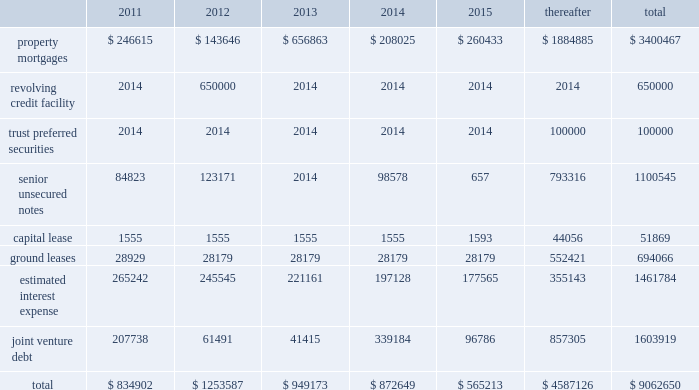Off-balance-sheet arrangements we have a number of off-balance-sheet investments , including joint ven- tures and debt and preferred equity investments .
These investments all have varying ownership structures .
Substantially all of our joint venture arrangements are accounted for under the equity method of accounting as we have the ability to exercise significant influence , but not control over the operating and financial decisions of these joint venture arrange- ments .
Our off-balance-sheet arrangements are discussed in note a0 5 , 201cdebt and preferred equity investments 201d and note a0 6 , 201cinvestments in unconsolidated joint ventures 201d in the accompanying consolidated finan- cial statements .
Additional information about the debt of our unconsoli- dated joint ventures is included in 201ccontractual obligations 201d below .
Capital expenditures we estimate that , for the year ending december a031 , 2011 , we will incur approximately $ 120.5 a0 million of capital expenditures , which are net of loan reserves ( including tenant improvements and leasing commis- sions ) , on existing wholly-owned properties , and that our share of capital expenditures at our joint venture properties , net of loan reserves , will be approximately $ 23.4 a0million .
We expect to fund these capital expen- ditures with operating cash flow , additional property level mortgage financings and cash on hand .
Future property acquisitions may require substantial capital investments for refurbishment and leasing costs .
We expect that these financing requirements will be met in a similar fashion .
We believe that we will have sufficient resources to satisfy our capital needs during the next 12-month period .
Thereafter , we expect our capital needs will be met through a combination of cash on hand , net cash provided by operations , borrowings , potential asset sales or addi- tional equity or debt issuances .
Above provides that , except to enable us to continue to qualify as a reit for federal income tax purposes , we will not during any four consecu- tive fiscal quarters make distributions with respect to common stock or other equity interests in an aggregate amount in excess of 95% ( 95 % ) of funds from operations for such period , subject to certain other adjustments .
As of december a0 31 , 2010 and 2009 , we were in compliance with all such covenants .
Market rate risk we are exposed to changes in interest rates primarily from our floating rate borrowing arrangements .
We use interest rate derivative instruments to manage exposure to interest rate changes .
A hypothetical 100 basis point increase in interest rates along the entire interest rate curve for 2010 and 2009 , would increase our annual interest cost by approximately $ 11.0 a0mil- lion and $ 15.2 a0million and would increase our share of joint venture annual interest cost by approximately $ 6.7 a0million and $ 6.4 a0million , respectively .
We recognize all derivatives on the balance sheet at fair value .
Derivatives that are not hedges must be adjusted to fair value through income .
If a derivative is a hedge , depending on the nature of the hedge , changes in the fair value of the derivative will either be offset against the change in fair value of the hedged asset , liability , or firm commitment through earnings , or recognized in other comprehensive income until the hedged item is recognized in earnings .
The ineffective portion of a deriva- tive 2019s change in fair value is recognized immediately in earnings .
Approximately $ 4.1 a0billion of our long-term debt bore interest at fixed rates , and therefore the fair value of these instruments is affected by changes in the market interest rates .
The interest rate on our variable rate debt and joint venture debt as of december a031 , 2010 ranged from libor plus 75 basis points to libor plus 400 basis points .
Contractual obligations combined aggregate principal maturities of mortgages and other loans payable , our 2007 unsecured revolving credit facility , senior unsecured notes ( net of discount ) , trust preferred securities , our share of joint venture debt , including as-of-right extension options , estimated interest expense ( based on weighted average interest rates for the quarter ) , and our obligations under our capital and ground leases , as of december a031 , 2010 , are as follows ( in thousands ) : .
48 sl green realty corp .
2010 annual report management 2019s discussion and analysis of financial condition and results of operations .
In 2011 what was the percent of the total contractual obligations associated with property mortgages? 
Computations: (246615 / 834902)
Answer: 0.29538. 